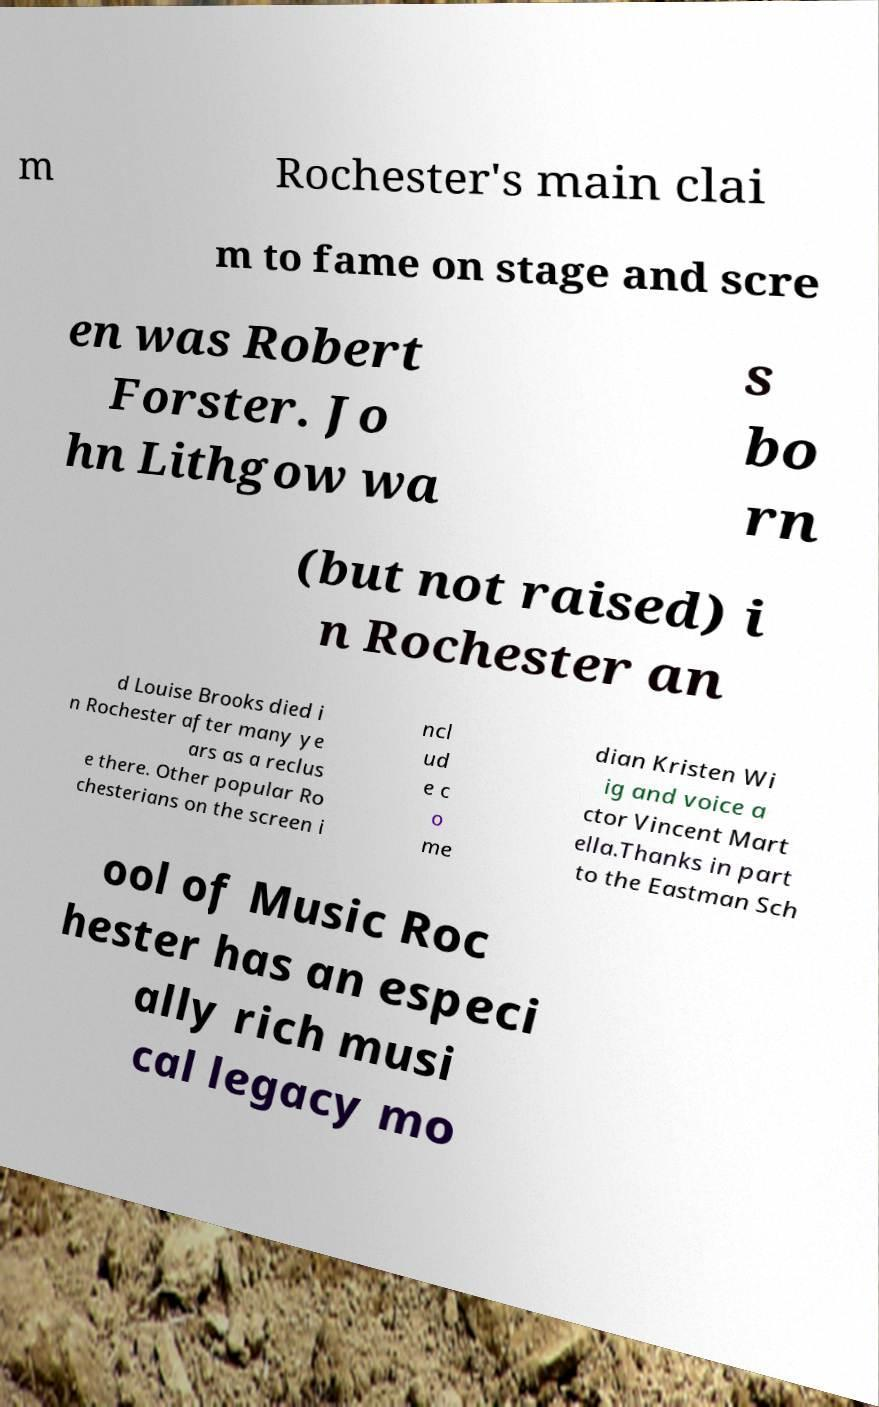For documentation purposes, I need the text within this image transcribed. Could you provide that? m Rochester's main clai m to fame on stage and scre en was Robert Forster. Jo hn Lithgow wa s bo rn (but not raised) i n Rochester an d Louise Brooks died i n Rochester after many ye ars as a reclus e there. Other popular Ro chesterians on the screen i ncl ud e c o me dian Kristen Wi ig and voice a ctor Vincent Mart ella.Thanks in part to the Eastman Sch ool of Music Roc hester has an especi ally rich musi cal legacy mo 